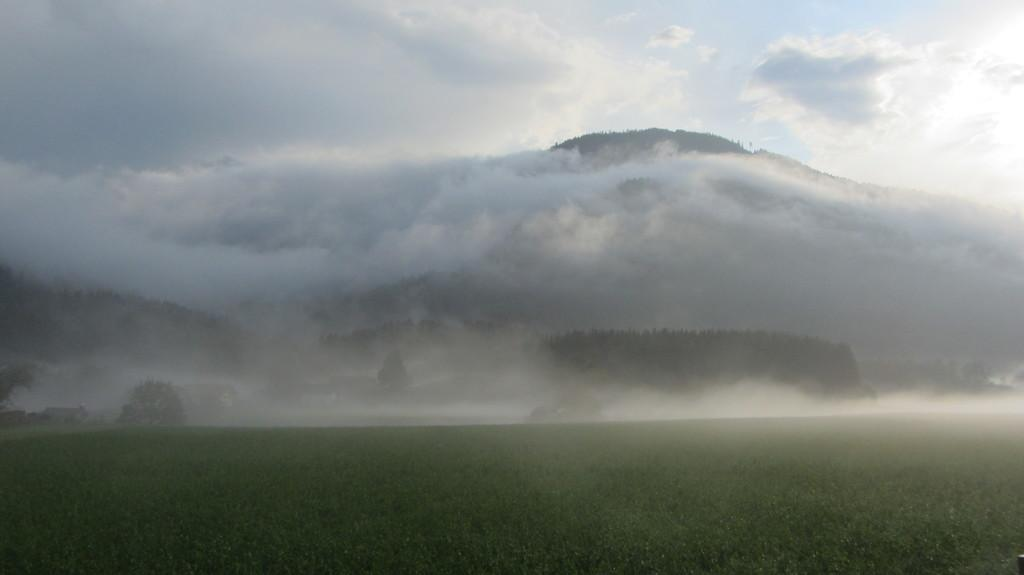What is the primary focus of the image? The image shows the ground. What type of vegetation can be seen in the image? There are trees in the image. What can be seen in the background of the image? The sky is visible in the background. What is the condition of the sky in the image? Clouds are present in the sky. What type of pipe is being used to control the flow of water in the image? There is no pipe or water present in the image; it shows the ground, trees, and the sky with clouds. 